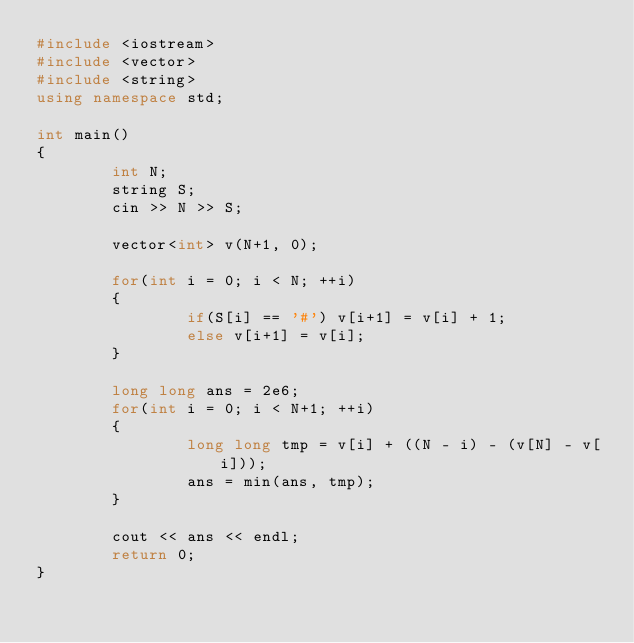<code> <loc_0><loc_0><loc_500><loc_500><_C++_>#include <iostream>
#include <vector>
#include <string>
using namespace std;

int main()
{
        int N;
        string S;
        cin >> N >> S;

        vector<int> v(N+1, 0);

        for(int i = 0; i < N; ++i)
        {
                if(S[i] == '#') v[i+1] = v[i] + 1;
                else v[i+1] = v[i];
        }

        long long ans = 2e6;
        for(int i = 0; i < N+1; ++i)
        {
                long long tmp = v[i] + ((N - i) - (v[N] - v[i]));
                ans = min(ans, tmp);
        }

        cout << ans << endl;
        return 0;
}</code> 